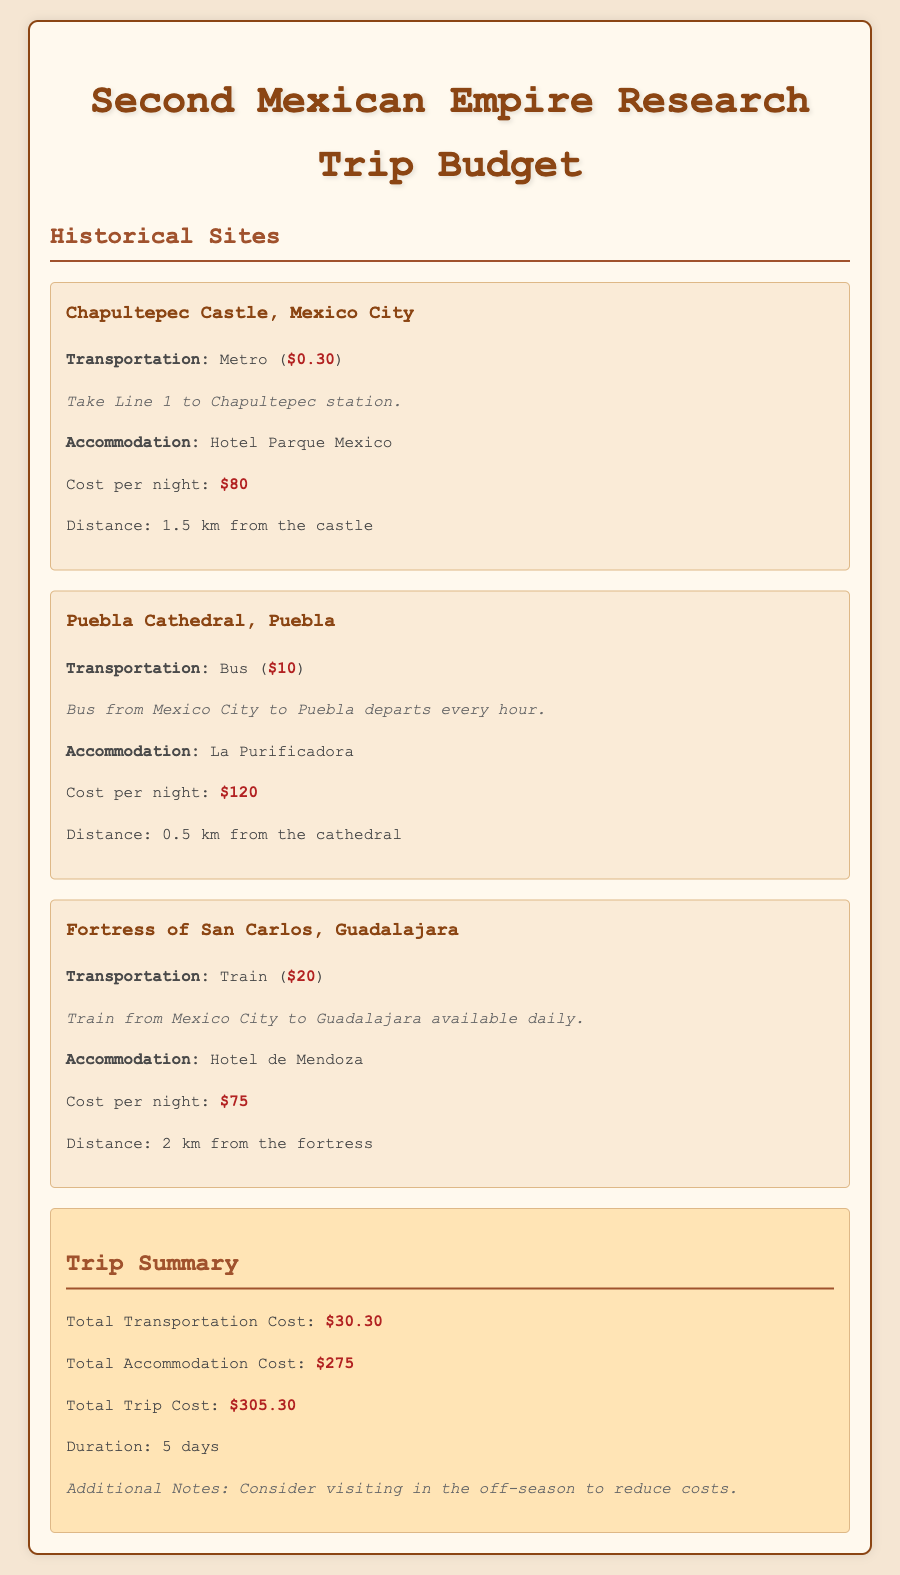What is the transportation cost to Chapultepec Castle? The transportation cost is listed under Chapultepec Castle as $0.30 for the Metro.
Answer: $0.30 What is the accommodation cost per night at La Purificadora? The accommodation cost per night for La Purificadora is mentioned as $120.
Answer: $120 How far is the Fortress of San Carlos from Hotel de Mendoza? The document states that Hotel de Mendoza is 2 km from the Fortress of San Carlos.
Answer: 2 km What is the total transportation cost for the trip? The total transportation cost is provided in the summary section as $30.30.
Answer: $30.30 What type of transportation is used to travel from Mexico City to Guadalajara? The type of transportation mentioned is Train.
Answer: Train What is the total trip cost? The total trip cost is summarized as $305.30 in the document.
Answer: $305.30 What hotel is located 1.5 km from Chapultepec Castle? The document specifies that Hotel Parque Mexico is located 1.5 km from Chapultepec Castle.
Answer: Hotel Parque Mexico What duration is suggested for the trip? The duration suggested is 5 days, as noted in the summary section.
Answer: 5 days 